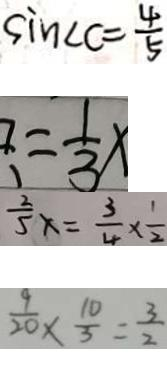Convert formula to latex. <formula><loc_0><loc_0><loc_500><loc_500>\sin \angle C = \frac { 4 } { 5 } 
 = \frac { 1 } { 3 } x 
 \frac { 2 } { 5 } x = \frac { 3 } { 4 } \times \frac { 1 } { 2 } 
 \frac { 9 } { 2 0 } \times \frac { 1 0 } { 3 } = \frac { 3 } { 2 }</formula> 